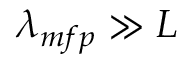<formula> <loc_0><loc_0><loc_500><loc_500>\lambda _ { m f p } \gg L</formula> 